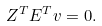Convert formula to latex. <formula><loc_0><loc_0><loc_500><loc_500>Z ^ { T } E ^ { T } v = 0 .</formula> 